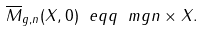Convert formula to latex. <formula><loc_0><loc_0><loc_500><loc_500>\overline { M } _ { g , n } ( X , 0 ) \ e q q \ m g n \times X .</formula> 